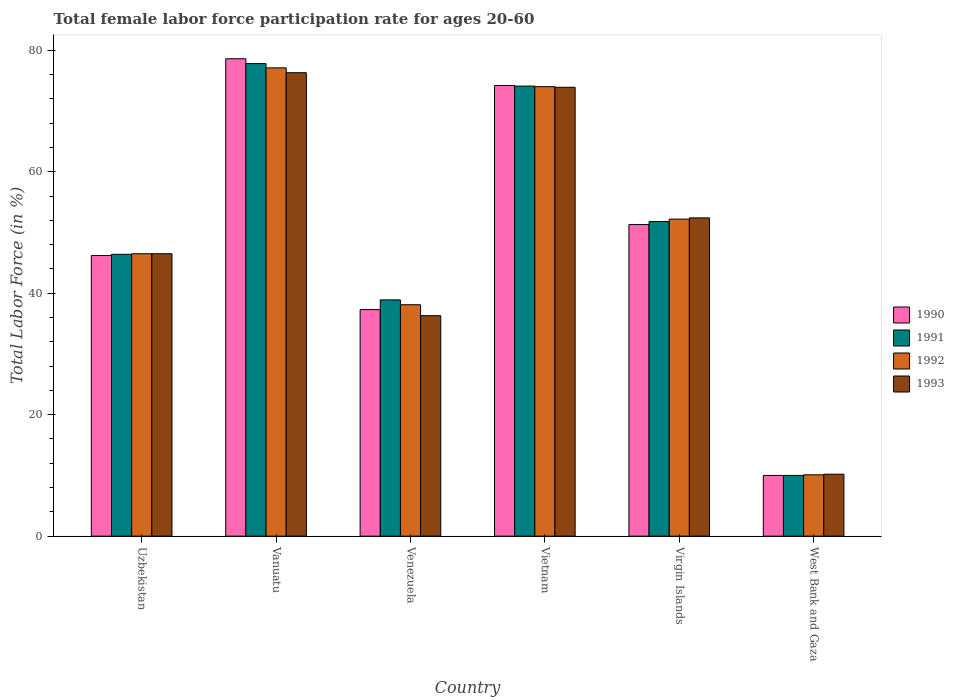How many groups of bars are there?
Offer a very short reply. 6. How many bars are there on the 1st tick from the left?
Offer a very short reply. 4. What is the label of the 5th group of bars from the left?
Your answer should be compact. Virgin Islands. What is the female labor force participation rate in 1991 in Virgin Islands?
Give a very brief answer. 51.8. Across all countries, what is the maximum female labor force participation rate in 1992?
Your answer should be compact. 77.1. Across all countries, what is the minimum female labor force participation rate in 1993?
Offer a very short reply. 10.2. In which country was the female labor force participation rate in 1990 maximum?
Make the answer very short. Vanuatu. In which country was the female labor force participation rate in 1992 minimum?
Provide a succinct answer. West Bank and Gaza. What is the total female labor force participation rate in 1993 in the graph?
Keep it short and to the point. 295.6. What is the difference between the female labor force participation rate in 1992 in Venezuela and that in Virgin Islands?
Your answer should be compact. -14.1. What is the difference between the female labor force participation rate in 1991 in Vanuatu and the female labor force participation rate in 1990 in West Bank and Gaza?
Your answer should be compact. 67.8. What is the average female labor force participation rate in 1992 per country?
Keep it short and to the point. 49.67. What is the ratio of the female labor force participation rate in 1992 in Vanuatu to that in West Bank and Gaza?
Ensure brevity in your answer.  7.63. Is the female labor force participation rate in 1991 in Uzbekistan less than that in Vanuatu?
Provide a succinct answer. Yes. What is the difference between the highest and the second highest female labor force participation rate in 1991?
Ensure brevity in your answer.  22.3. What is the difference between the highest and the lowest female labor force participation rate in 1992?
Keep it short and to the point. 67. In how many countries, is the female labor force participation rate in 1990 greater than the average female labor force participation rate in 1990 taken over all countries?
Your answer should be very brief. 3. Is it the case that in every country, the sum of the female labor force participation rate in 1993 and female labor force participation rate in 1991 is greater than the sum of female labor force participation rate in 1990 and female labor force participation rate in 1992?
Make the answer very short. No. What does the 4th bar from the right in Vanuatu represents?
Your response must be concise. 1990. Is it the case that in every country, the sum of the female labor force participation rate in 1991 and female labor force participation rate in 1992 is greater than the female labor force participation rate in 1993?
Make the answer very short. Yes. How many bars are there?
Provide a short and direct response. 24. Are all the bars in the graph horizontal?
Keep it short and to the point. No. Does the graph contain grids?
Provide a short and direct response. No. How are the legend labels stacked?
Offer a terse response. Vertical. What is the title of the graph?
Provide a succinct answer. Total female labor force participation rate for ages 20-60. Does "1974" appear as one of the legend labels in the graph?
Keep it short and to the point. No. What is the label or title of the X-axis?
Keep it short and to the point. Country. What is the Total Labor Force (in %) in 1990 in Uzbekistan?
Your answer should be very brief. 46.2. What is the Total Labor Force (in %) of 1991 in Uzbekistan?
Provide a short and direct response. 46.4. What is the Total Labor Force (in %) of 1992 in Uzbekistan?
Give a very brief answer. 46.5. What is the Total Labor Force (in %) in 1993 in Uzbekistan?
Your response must be concise. 46.5. What is the Total Labor Force (in %) in 1990 in Vanuatu?
Offer a terse response. 78.6. What is the Total Labor Force (in %) in 1991 in Vanuatu?
Give a very brief answer. 77.8. What is the Total Labor Force (in %) of 1992 in Vanuatu?
Your answer should be compact. 77.1. What is the Total Labor Force (in %) in 1993 in Vanuatu?
Your answer should be very brief. 76.3. What is the Total Labor Force (in %) of 1990 in Venezuela?
Provide a succinct answer. 37.3. What is the Total Labor Force (in %) in 1991 in Venezuela?
Make the answer very short. 38.9. What is the Total Labor Force (in %) in 1992 in Venezuela?
Offer a very short reply. 38.1. What is the Total Labor Force (in %) in 1993 in Venezuela?
Keep it short and to the point. 36.3. What is the Total Labor Force (in %) in 1990 in Vietnam?
Give a very brief answer. 74.2. What is the Total Labor Force (in %) in 1991 in Vietnam?
Ensure brevity in your answer.  74.1. What is the Total Labor Force (in %) of 1993 in Vietnam?
Provide a succinct answer. 73.9. What is the Total Labor Force (in %) of 1990 in Virgin Islands?
Ensure brevity in your answer.  51.3. What is the Total Labor Force (in %) in 1991 in Virgin Islands?
Your response must be concise. 51.8. What is the Total Labor Force (in %) of 1992 in Virgin Islands?
Your response must be concise. 52.2. What is the Total Labor Force (in %) of 1993 in Virgin Islands?
Provide a succinct answer. 52.4. What is the Total Labor Force (in %) in 1990 in West Bank and Gaza?
Offer a terse response. 10. What is the Total Labor Force (in %) in 1991 in West Bank and Gaza?
Keep it short and to the point. 10. What is the Total Labor Force (in %) in 1992 in West Bank and Gaza?
Offer a terse response. 10.1. What is the Total Labor Force (in %) in 1993 in West Bank and Gaza?
Make the answer very short. 10.2. Across all countries, what is the maximum Total Labor Force (in %) of 1990?
Offer a terse response. 78.6. Across all countries, what is the maximum Total Labor Force (in %) in 1991?
Ensure brevity in your answer.  77.8. Across all countries, what is the maximum Total Labor Force (in %) of 1992?
Offer a terse response. 77.1. Across all countries, what is the maximum Total Labor Force (in %) of 1993?
Your answer should be very brief. 76.3. Across all countries, what is the minimum Total Labor Force (in %) in 1992?
Give a very brief answer. 10.1. Across all countries, what is the minimum Total Labor Force (in %) in 1993?
Offer a very short reply. 10.2. What is the total Total Labor Force (in %) in 1990 in the graph?
Offer a very short reply. 297.6. What is the total Total Labor Force (in %) in 1991 in the graph?
Make the answer very short. 299. What is the total Total Labor Force (in %) in 1992 in the graph?
Offer a very short reply. 298. What is the total Total Labor Force (in %) of 1993 in the graph?
Ensure brevity in your answer.  295.6. What is the difference between the Total Labor Force (in %) of 1990 in Uzbekistan and that in Vanuatu?
Your response must be concise. -32.4. What is the difference between the Total Labor Force (in %) in 1991 in Uzbekistan and that in Vanuatu?
Offer a very short reply. -31.4. What is the difference between the Total Labor Force (in %) in 1992 in Uzbekistan and that in Vanuatu?
Your response must be concise. -30.6. What is the difference between the Total Labor Force (in %) of 1993 in Uzbekistan and that in Vanuatu?
Keep it short and to the point. -29.8. What is the difference between the Total Labor Force (in %) of 1991 in Uzbekistan and that in Venezuela?
Offer a very short reply. 7.5. What is the difference between the Total Labor Force (in %) in 1992 in Uzbekistan and that in Venezuela?
Offer a very short reply. 8.4. What is the difference between the Total Labor Force (in %) of 1991 in Uzbekistan and that in Vietnam?
Keep it short and to the point. -27.7. What is the difference between the Total Labor Force (in %) in 1992 in Uzbekistan and that in Vietnam?
Your response must be concise. -27.5. What is the difference between the Total Labor Force (in %) of 1993 in Uzbekistan and that in Vietnam?
Provide a short and direct response. -27.4. What is the difference between the Total Labor Force (in %) in 1990 in Uzbekistan and that in Virgin Islands?
Your answer should be compact. -5.1. What is the difference between the Total Labor Force (in %) of 1991 in Uzbekistan and that in Virgin Islands?
Keep it short and to the point. -5.4. What is the difference between the Total Labor Force (in %) in 1990 in Uzbekistan and that in West Bank and Gaza?
Provide a succinct answer. 36.2. What is the difference between the Total Labor Force (in %) in 1991 in Uzbekistan and that in West Bank and Gaza?
Offer a very short reply. 36.4. What is the difference between the Total Labor Force (in %) in 1992 in Uzbekistan and that in West Bank and Gaza?
Provide a succinct answer. 36.4. What is the difference between the Total Labor Force (in %) of 1993 in Uzbekistan and that in West Bank and Gaza?
Provide a short and direct response. 36.3. What is the difference between the Total Labor Force (in %) of 1990 in Vanuatu and that in Venezuela?
Provide a succinct answer. 41.3. What is the difference between the Total Labor Force (in %) of 1991 in Vanuatu and that in Venezuela?
Your answer should be very brief. 38.9. What is the difference between the Total Labor Force (in %) of 1990 in Vanuatu and that in Vietnam?
Your answer should be compact. 4.4. What is the difference between the Total Labor Force (in %) of 1991 in Vanuatu and that in Vietnam?
Keep it short and to the point. 3.7. What is the difference between the Total Labor Force (in %) in 1992 in Vanuatu and that in Vietnam?
Your answer should be very brief. 3.1. What is the difference between the Total Labor Force (in %) of 1993 in Vanuatu and that in Vietnam?
Provide a succinct answer. 2.4. What is the difference between the Total Labor Force (in %) of 1990 in Vanuatu and that in Virgin Islands?
Ensure brevity in your answer.  27.3. What is the difference between the Total Labor Force (in %) in 1991 in Vanuatu and that in Virgin Islands?
Keep it short and to the point. 26. What is the difference between the Total Labor Force (in %) of 1992 in Vanuatu and that in Virgin Islands?
Keep it short and to the point. 24.9. What is the difference between the Total Labor Force (in %) of 1993 in Vanuatu and that in Virgin Islands?
Provide a succinct answer. 23.9. What is the difference between the Total Labor Force (in %) of 1990 in Vanuatu and that in West Bank and Gaza?
Ensure brevity in your answer.  68.6. What is the difference between the Total Labor Force (in %) of 1991 in Vanuatu and that in West Bank and Gaza?
Ensure brevity in your answer.  67.8. What is the difference between the Total Labor Force (in %) in 1992 in Vanuatu and that in West Bank and Gaza?
Keep it short and to the point. 67. What is the difference between the Total Labor Force (in %) in 1993 in Vanuatu and that in West Bank and Gaza?
Ensure brevity in your answer.  66.1. What is the difference between the Total Labor Force (in %) in 1990 in Venezuela and that in Vietnam?
Make the answer very short. -36.9. What is the difference between the Total Labor Force (in %) of 1991 in Venezuela and that in Vietnam?
Your answer should be very brief. -35.2. What is the difference between the Total Labor Force (in %) of 1992 in Venezuela and that in Vietnam?
Offer a very short reply. -35.9. What is the difference between the Total Labor Force (in %) of 1993 in Venezuela and that in Vietnam?
Provide a short and direct response. -37.6. What is the difference between the Total Labor Force (in %) in 1990 in Venezuela and that in Virgin Islands?
Offer a terse response. -14. What is the difference between the Total Labor Force (in %) of 1992 in Venezuela and that in Virgin Islands?
Make the answer very short. -14.1. What is the difference between the Total Labor Force (in %) of 1993 in Venezuela and that in Virgin Islands?
Your answer should be very brief. -16.1. What is the difference between the Total Labor Force (in %) in 1990 in Venezuela and that in West Bank and Gaza?
Keep it short and to the point. 27.3. What is the difference between the Total Labor Force (in %) of 1991 in Venezuela and that in West Bank and Gaza?
Ensure brevity in your answer.  28.9. What is the difference between the Total Labor Force (in %) of 1992 in Venezuela and that in West Bank and Gaza?
Give a very brief answer. 28. What is the difference between the Total Labor Force (in %) in 1993 in Venezuela and that in West Bank and Gaza?
Make the answer very short. 26.1. What is the difference between the Total Labor Force (in %) in 1990 in Vietnam and that in Virgin Islands?
Ensure brevity in your answer.  22.9. What is the difference between the Total Labor Force (in %) in 1991 in Vietnam and that in Virgin Islands?
Your answer should be compact. 22.3. What is the difference between the Total Labor Force (in %) of 1992 in Vietnam and that in Virgin Islands?
Keep it short and to the point. 21.8. What is the difference between the Total Labor Force (in %) in 1990 in Vietnam and that in West Bank and Gaza?
Your response must be concise. 64.2. What is the difference between the Total Labor Force (in %) of 1991 in Vietnam and that in West Bank and Gaza?
Your answer should be very brief. 64.1. What is the difference between the Total Labor Force (in %) in 1992 in Vietnam and that in West Bank and Gaza?
Offer a very short reply. 63.9. What is the difference between the Total Labor Force (in %) of 1993 in Vietnam and that in West Bank and Gaza?
Offer a terse response. 63.7. What is the difference between the Total Labor Force (in %) of 1990 in Virgin Islands and that in West Bank and Gaza?
Make the answer very short. 41.3. What is the difference between the Total Labor Force (in %) of 1991 in Virgin Islands and that in West Bank and Gaza?
Provide a succinct answer. 41.8. What is the difference between the Total Labor Force (in %) in 1992 in Virgin Islands and that in West Bank and Gaza?
Provide a short and direct response. 42.1. What is the difference between the Total Labor Force (in %) in 1993 in Virgin Islands and that in West Bank and Gaza?
Offer a very short reply. 42.2. What is the difference between the Total Labor Force (in %) of 1990 in Uzbekistan and the Total Labor Force (in %) of 1991 in Vanuatu?
Keep it short and to the point. -31.6. What is the difference between the Total Labor Force (in %) in 1990 in Uzbekistan and the Total Labor Force (in %) in 1992 in Vanuatu?
Keep it short and to the point. -30.9. What is the difference between the Total Labor Force (in %) of 1990 in Uzbekistan and the Total Labor Force (in %) of 1993 in Vanuatu?
Your answer should be very brief. -30.1. What is the difference between the Total Labor Force (in %) in 1991 in Uzbekistan and the Total Labor Force (in %) in 1992 in Vanuatu?
Your answer should be compact. -30.7. What is the difference between the Total Labor Force (in %) of 1991 in Uzbekistan and the Total Labor Force (in %) of 1993 in Vanuatu?
Give a very brief answer. -29.9. What is the difference between the Total Labor Force (in %) in 1992 in Uzbekistan and the Total Labor Force (in %) in 1993 in Vanuatu?
Your response must be concise. -29.8. What is the difference between the Total Labor Force (in %) in 1990 in Uzbekistan and the Total Labor Force (in %) in 1991 in Venezuela?
Give a very brief answer. 7.3. What is the difference between the Total Labor Force (in %) of 1990 in Uzbekistan and the Total Labor Force (in %) of 1993 in Venezuela?
Offer a very short reply. 9.9. What is the difference between the Total Labor Force (in %) of 1991 in Uzbekistan and the Total Labor Force (in %) of 1993 in Venezuela?
Provide a succinct answer. 10.1. What is the difference between the Total Labor Force (in %) of 1990 in Uzbekistan and the Total Labor Force (in %) of 1991 in Vietnam?
Ensure brevity in your answer.  -27.9. What is the difference between the Total Labor Force (in %) of 1990 in Uzbekistan and the Total Labor Force (in %) of 1992 in Vietnam?
Keep it short and to the point. -27.8. What is the difference between the Total Labor Force (in %) in 1990 in Uzbekistan and the Total Labor Force (in %) in 1993 in Vietnam?
Your response must be concise. -27.7. What is the difference between the Total Labor Force (in %) of 1991 in Uzbekistan and the Total Labor Force (in %) of 1992 in Vietnam?
Your answer should be very brief. -27.6. What is the difference between the Total Labor Force (in %) of 1991 in Uzbekistan and the Total Labor Force (in %) of 1993 in Vietnam?
Provide a short and direct response. -27.5. What is the difference between the Total Labor Force (in %) in 1992 in Uzbekistan and the Total Labor Force (in %) in 1993 in Vietnam?
Provide a succinct answer. -27.4. What is the difference between the Total Labor Force (in %) of 1990 in Uzbekistan and the Total Labor Force (in %) of 1991 in Virgin Islands?
Offer a very short reply. -5.6. What is the difference between the Total Labor Force (in %) of 1990 in Uzbekistan and the Total Labor Force (in %) of 1993 in Virgin Islands?
Your answer should be very brief. -6.2. What is the difference between the Total Labor Force (in %) of 1991 in Uzbekistan and the Total Labor Force (in %) of 1992 in Virgin Islands?
Make the answer very short. -5.8. What is the difference between the Total Labor Force (in %) in 1990 in Uzbekistan and the Total Labor Force (in %) in 1991 in West Bank and Gaza?
Offer a terse response. 36.2. What is the difference between the Total Labor Force (in %) in 1990 in Uzbekistan and the Total Labor Force (in %) in 1992 in West Bank and Gaza?
Your answer should be compact. 36.1. What is the difference between the Total Labor Force (in %) of 1990 in Uzbekistan and the Total Labor Force (in %) of 1993 in West Bank and Gaza?
Provide a short and direct response. 36. What is the difference between the Total Labor Force (in %) in 1991 in Uzbekistan and the Total Labor Force (in %) in 1992 in West Bank and Gaza?
Your answer should be compact. 36.3. What is the difference between the Total Labor Force (in %) of 1991 in Uzbekistan and the Total Labor Force (in %) of 1993 in West Bank and Gaza?
Make the answer very short. 36.2. What is the difference between the Total Labor Force (in %) of 1992 in Uzbekistan and the Total Labor Force (in %) of 1993 in West Bank and Gaza?
Provide a succinct answer. 36.3. What is the difference between the Total Labor Force (in %) of 1990 in Vanuatu and the Total Labor Force (in %) of 1991 in Venezuela?
Make the answer very short. 39.7. What is the difference between the Total Labor Force (in %) of 1990 in Vanuatu and the Total Labor Force (in %) of 1992 in Venezuela?
Give a very brief answer. 40.5. What is the difference between the Total Labor Force (in %) of 1990 in Vanuatu and the Total Labor Force (in %) of 1993 in Venezuela?
Give a very brief answer. 42.3. What is the difference between the Total Labor Force (in %) of 1991 in Vanuatu and the Total Labor Force (in %) of 1992 in Venezuela?
Offer a very short reply. 39.7. What is the difference between the Total Labor Force (in %) in 1991 in Vanuatu and the Total Labor Force (in %) in 1993 in Venezuela?
Offer a terse response. 41.5. What is the difference between the Total Labor Force (in %) in 1992 in Vanuatu and the Total Labor Force (in %) in 1993 in Venezuela?
Your response must be concise. 40.8. What is the difference between the Total Labor Force (in %) of 1990 in Vanuatu and the Total Labor Force (in %) of 1991 in Vietnam?
Offer a terse response. 4.5. What is the difference between the Total Labor Force (in %) of 1990 in Vanuatu and the Total Labor Force (in %) of 1992 in Vietnam?
Ensure brevity in your answer.  4.6. What is the difference between the Total Labor Force (in %) in 1990 in Vanuatu and the Total Labor Force (in %) in 1993 in Vietnam?
Your answer should be compact. 4.7. What is the difference between the Total Labor Force (in %) in 1991 in Vanuatu and the Total Labor Force (in %) in 1993 in Vietnam?
Your answer should be very brief. 3.9. What is the difference between the Total Labor Force (in %) in 1992 in Vanuatu and the Total Labor Force (in %) in 1993 in Vietnam?
Offer a very short reply. 3.2. What is the difference between the Total Labor Force (in %) of 1990 in Vanuatu and the Total Labor Force (in %) of 1991 in Virgin Islands?
Your answer should be compact. 26.8. What is the difference between the Total Labor Force (in %) in 1990 in Vanuatu and the Total Labor Force (in %) in 1992 in Virgin Islands?
Your response must be concise. 26.4. What is the difference between the Total Labor Force (in %) of 1990 in Vanuatu and the Total Labor Force (in %) of 1993 in Virgin Islands?
Ensure brevity in your answer.  26.2. What is the difference between the Total Labor Force (in %) of 1991 in Vanuatu and the Total Labor Force (in %) of 1992 in Virgin Islands?
Give a very brief answer. 25.6. What is the difference between the Total Labor Force (in %) in 1991 in Vanuatu and the Total Labor Force (in %) in 1993 in Virgin Islands?
Offer a terse response. 25.4. What is the difference between the Total Labor Force (in %) in 1992 in Vanuatu and the Total Labor Force (in %) in 1993 in Virgin Islands?
Your answer should be compact. 24.7. What is the difference between the Total Labor Force (in %) in 1990 in Vanuatu and the Total Labor Force (in %) in 1991 in West Bank and Gaza?
Your answer should be very brief. 68.6. What is the difference between the Total Labor Force (in %) of 1990 in Vanuatu and the Total Labor Force (in %) of 1992 in West Bank and Gaza?
Keep it short and to the point. 68.5. What is the difference between the Total Labor Force (in %) in 1990 in Vanuatu and the Total Labor Force (in %) in 1993 in West Bank and Gaza?
Your answer should be very brief. 68.4. What is the difference between the Total Labor Force (in %) in 1991 in Vanuatu and the Total Labor Force (in %) in 1992 in West Bank and Gaza?
Ensure brevity in your answer.  67.7. What is the difference between the Total Labor Force (in %) of 1991 in Vanuatu and the Total Labor Force (in %) of 1993 in West Bank and Gaza?
Your answer should be compact. 67.6. What is the difference between the Total Labor Force (in %) in 1992 in Vanuatu and the Total Labor Force (in %) in 1993 in West Bank and Gaza?
Offer a very short reply. 66.9. What is the difference between the Total Labor Force (in %) in 1990 in Venezuela and the Total Labor Force (in %) in 1991 in Vietnam?
Make the answer very short. -36.8. What is the difference between the Total Labor Force (in %) of 1990 in Venezuela and the Total Labor Force (in %) of 1992 in Vietnam?
Give a very brief answer. -36.7. What is the difference between the Total Labor Force (in %) in 1990 in Venezuela and the Total Labor Force (in %) in 1993 in Vietnam?
Make the answer very short. -36.6. What is the difference between the Total Labor Force (in %) of 1991 in Venezuela and the Total Labor Force (in %) of 1992 in Vietnam?
Your response must be concise. -35.1. What is the difference between the Total Labor Force (in %) of 1991 in Venezuela and the Total Labor Force (in %) of 1993 in Vietnam?
Your answer should be very brief. -35. What is the difference between the Total Labor Force (in %) in 1992 in Venezuela and the Total Labor Force (in %) in 1993 in Vietnam?
Keep it short and to the point. -35.8. What is the difference between the Total Labor Force (in %) of 1990 in Venezuela and the Total Labor Force (in %) of 1991 in Virgin Islands?
Your response must be concise. -14.5. What is the difference between the Total Labor Force (in %) in 1990 in Venezuela and the Total Labor Force (in %) in 1992 in Virgin Islands?
Keep it short and to the point. -14.9. What is the difference between the Total Labor Force (in %) of 1990 in Venezuela and the Total Labor Force (in %) of 1993 in Virgin Islands?
Offer a terse response. -15.1. What is the difference between the Total Labor Force (in %) in 1992 in Venezuela and the Total Labor Force (in %) in 1993 in Virgin Islands?
Provide a succinct answer. -14.3. What is the difference between the Total Labor Force (in %) in 1990 in Venezuela and the Total Labor Force (in %) in 1991 in West Bank and Gaza?
Ensure brevity in your answer.  27.3. What is the difference between the Total Labor Force (in %) in 1990 in Venezuela and the Total Labor Force (in %) in 1992 in West Bank and Gaza?
Your response must be concise. 27.2. What is the difference between the Total Labor Force (in %) in 1990 in Venezuela and the Total Labor Force (in %) in 1993 in West Bank and Gaza?
Your answer should be very brief. 27.1. What is the difference between the Total Labor Force (in %) of 1991 in Venezuela and the Total Labor Force (in %) of 1992 in West Bank and Gaza?
Your answer should be compact. 28.8. What is the difference between the Total Labor Force (in %) of 1991 in Venezuela and the Total Labor Force (in %) of 1993 in West Bank and Gaza?
Offer a very short reply. 28.7. What is the difference between the Total Labor Force (in %) in 1992 in Venezuela and the Total Labor Force (in %) in 1993 in West Bank and Gaza?
Provide a short and direct response. 27.9. What is the difference between the Total Labor Force (in %) of 1990 in Vietnam and the Total Labor Force (in %) of 1991 in Virgin Islands?
Provide a succinct answer. 22.4. What is the difference between the Total Labor Force (in %) in 1990 in Vietnam and the Total Labor Force (in %) in 1992 in Virgin Islands?
Provide a succinct answer. 22. What is the difference between the Total Labor Force (in %) in 1990 in Vietnam and the Total Labor Force (in %) in 1993 in Virgin Islands?
Your answer should be very brief. 21.8. What is the difference between the Total Labor Force (in %) of 1991 in Vietnam and the Total Labor Force (in %) of 1992 in Virgin Islands?
Give a very brief answer. 21.9. What is the difference between the Total Labor Force (in %) in 1991 in Vietnam and the Total Labor Force (in %) in 1993 in Virgin Islands?
Offer a very short reply. 21.7. What is the difference between the Total Labor Force (in %) of 1992 in Vietnam and the Total Labor Force (in %) of 1993 in Virgin Islands?
Make the answer very short. 21.6. What is the difference between the Total Labor Force (in %) of 1990 in Vietnam and the Total Labor Force (in %) of 1991 in West Bank and Gaza?
Give a very brief answer. 64.2. What is the difference between the Total Labor Force (in %) of 1990 in Vietnam and the Total Labor Force (in %) of 1992 in West Bank and Gaza?
Your answer should be compact. 64.1. What is the difference between the Total Labor Force (in %) of 1991 in Vietnam and the Total Labor Force (in %) of 1992 in West Bank and Gaza?
Offer a very short reply. 64. What is the difference between the Total Labor Force (in %) in 1991 in Vietnam and the Total Labor Force (in %) in 1993 in West Bank and Gaza?
Give a very brief answer. 63.9. What is the difference between the Total Labor Force (in %) of 1992 in Vietnam and the Total Labor Force (in %) of 1993 in West Bank and Gaza?
Your response must be concise. 63.8. What is the difference between the Total Labor Force (in %) of 1990 in Virgin Islands and the Total Labor Force (in %) of 1991 in West Bank and Gaza?
Ensure brevity in your answer.  41.3. What is the difference between the Total Labor Force (in %) in 1990 in Virgin Islands and the Total Labor Force (in %) in 1992 in West Bank and Gaza?
Provide a short and direct response. 41.2. What is the difference between the Total Labor Force (in %) in 1990 in Virgin Islands and the Total Labor Force (in %) in 1993 in West Bank and Gaza?
Your answer should be very brief. 41.1. What is the difference between the Total Labor Force (in %) in 1991 in Virgin Islands and the Total Labor Force (in %) in 1992 in West Bank and Gaza?
Offer a very short reply. 41.7. What is the difference between the Total Labor Force (in %) in 1991 in Virgin Islands and the Total Labor Force (in %) in 1993 in West Bank and Gaza?
Keep it short and to the point. 41.6. What is the average Total Labor Force (in %) in 1990 per country?
Make the answer very short. 49.6. What is the average Total Labor Force (in %) in 1991 per country?
Offer a terse response. 49.83. What is the average Total Labor Force (in %) of 1992 per country?
Make the answer very short. 49.67. What is the average Total Labor Force (in %) of 1993 per country?
Make the answer very short. 49.27. What is the difference between the Total Labor Force (in %) of 1990 and Total Labor Force (in %) of 1991 in Uzbekistan?
Your response must be concise. -0.2. What is the difference between the Total Labor Force (in %) in 1990 and Total Labor Force (in %) in 1993 in Uzbekistan?
Your answer should be compact. -0.3. What is the difference between the Total Labor Force (in %) of 1991 and Total Labor Force (in %) of 1992 in Uzbekistan?
Ensure brevity in your answer.  -0.1. What is the difference between the Total Labor Force (in %) of 1991 and Total Labor Force (in %) of 1992 in Vanuatu?
Your answer should be very brief. 0.7. What is the difference between the Total Labor Force (in %) of 1991 and Total Labor Force (in %) of 1993 in Vanuatu?
Give a very brief answer. 1.5. What is the difference between the Total Labor Force (in %) of 1990 and Total Labor Force (in %) of 1993 in Venezuela?
Keep it short and to the point. 1. What is the difference between the Total Labor Force (in %) in 1991 and Total Labor Force (in %) in 1992 in Venezuela?
Keep it short and to the point. 0.8. What is the difference between the Total Labor Force (in %) of 1991 and Total Labor Force (in %) of 1993 in Venezuela?
Give a very brief answer. 2.6. What is the difference between the Total Labor Force (in %) in 1992 and Total Labor Force (in %) in 1993 in Venezuela?
Make the answer very short. 1.8. What is the difference between the Total Labor Force (in %) of 1990 and Total Labor Force (in %) of 1991 in Vietnam?
Your answer should be compact. 0.1. What is the difference between the Total Labor Force (in %) in 1990 and Total Labor Force (in %) in 1992 in Vietnam?
Make the answer very short. 0.2. What is the difference between the Total Labor Force (in %) in 1990 and Total Labor Force (in %) in 1993 in Vietnam?
Provide a short and direct response. 0.3. What is the difference between the Total Labor Force (in %) of 1991 and Total Labor Force (in %) of 1993 in Vietnam?
Your answer should be compact. 0.2. What is the difference between the Total Labor Force (in %) of 1990 and Total Labor Force (in %) of 1993 in Virgin Islands?
Provide a succinct answer. -1.1. What is the difference between the Total Labor Force (in %) of 1991 and Total Labor Force (in %) of 1993 in Virgin Islands?
Make the answer very short. -0.6. What is the difference between the Total Labor Force (in %) of 1992 and Total Labor Force (in %) of 1993 in Virgin Islands?
Provide a succinct answer. -0.2. What is the difference between the Total Labor Force (in %) of 1990 and Total Labor Force (in %) of 1992 in West Bank and Gaza?
Your response must be concise. -0.1. What is the difference between the Total Labor Force (in %) in 1990 and Total Labor Force (in %) in 1993 in West Bank and Gaza?
Your answer should be compact. -0.2. What is the difference between the Total Labor Force (in %) in 1991 and Total Labor Force (in %) in 1992 in West Bank and Gaza?
Offer a very short reply. -0.1. What is the difference between the Total Labor Force (in %) of 1992 and Total Labor Force (in %) of 1993 in West Bank and Gaza?
Ensure brevity in your answer.  -0.1. What is the ratio of the Total Labor Force (in %) of 1990 in Uzbekistan to that in Vanuatu?
Provide a succinct answer. 0.59. What is the ratio of the Total Labor Force (in %) in 1991 in Uzbekistan to that in Vanuatu?
Provide a succinct answer. 0.6. What is the ratio of the Total Labor Force (in %) in 1992 in Uzbekistan to that in Vanuatu?
Ensure brevity in your answer.  0.6. What is the ratio of the Total Labor Force (in %) in 1993 in Uzbekistan to that in Vanuatu?
Keep it short and to the point. 0.61. What is the ratio of the Total Labor Force (in %) of 1990 in Uzbekistan to that in Venezuela?
Ensure brevity in your answer.  1.24. What is the ratio of the Total Labor Force (in %) in 1991 in Uzbekistan to that in Venezuela?
Your answer should be compact. 1.19. What is the ratio of the Total Labor Force (in %) of 1992 in Uzbekistan to that in Venezuela?
Give a very brief answer. 1.22. What is the ratio of the Total Labor Force (in %) in 1993 in Uzbekistan to that in Venezuela?
Keep it short and to the point. 1.28. What is the ratio of the Total Labor Force (in %) of 1990 in Uzbekistan to that in Vietnam?
Provide a succinct answer. 0.62. What is the ratio of the Total Labor Force (in %) in 1991 in Uzbekistan to that in Vietnam?
Give a very brief answer. 0.63. What is the ratio of the Total Labor Force (in %) of 1992 in Uzbekistan to that in Vietnam?
Give a very brief answer. 0.63. What is the ratio of the Total Labor Force (in %) of 1993 in Uzbekistan to that in Vietnam?
Offer a very short reply. 0.63. What is the ratio of the Total Labor Force (in %) of 1990 in Uzbekistan to that in Virgin Islands?
Your answer should be compact. 0.9. What is the ratio of the Total Labor Force (in %) in 1991 in Uzbekistan to that in Virgin Islands?
Your answer should be compact. 0.9. What is the ratio of the Total Labor Force (in %) in 1992 in Uzbekistan to that in Virgin Islands?
Offer a very short reply. 0.89. What is the ratio of the Total Labor Force (in %) in 1993 in Uzbekistan to that in Virgin Islands?
Keep it short and to the point. 0.89. What is the ratio of the Total Labor Force (in %) of 1990 in Uzbekistan to that in West Bank and Gaza?
Provide a short and direct response. 4.62. What is the ratio of the Total Labor Force (in %) in 1991 in Uzbekistan to that in West Bank and Gaza?
Your response must be concise. 4.64. What is the ratio of the Total Labor Force (in %) in 1992 in Uzbekistan to that in West Bank and Gaza?
Offer a terse response. 4.6. What is the ratio of the Total Labor Force (in %) in 1993 in Uzbekistan to that in West Bank and Gaza?
Give a very brief answer. 4.56. What is the ratio of the Total Labor Force (in %) of 1990 in Vanuatu to that in Venezuela?
Your response must be concise. 2.11. What is the ratio of the Total Labor Force (in %) in 1992 in Vanuatu to that in Venezuela?
Ensure brevity in your answer.  2.02. What is the ratio of the Total Labor Force (in %) of 1993 in Vanuatu to that in Venezuela?
Offer a very short reply. 2.1. What is the ratio of the Total Labor Force (in %) of 1990 in Vanuatu to that in Vietnam?
Your response must be concise. 1.06. What is the ratio of the Total Labor Force (in %) in 1991 in Vanuatu to that in Vietnam?
Give a very brief answer. 1.05. What is the ratio of the Total Labor Force (in %) of 1992 in Vanuatu to that in Vietnam?
Give a very brief answer. 1.04. What is the ratio of the Total Labor Force (in %) in 1993 in Vanuatu to that in Vietnam?
Offer a very short reply. 1.03. What is the ratio of the Total Labor Force (in %) in 1990 in Vanuatu to that in Virgin Islands?
Provide a succinct answer. 1.53. What is the ratio of the Total Labor Force (in %) in 1991 in Vanuatu to that in Virgin Islands?
Ensure brevity in your answer.  1.5. What is the ratio of the Total Labor Force (in %) of 1992 in Vanuatu to that in Virgin Islands?
Offer a terse response. 1.48. What is the ratio of the Total Labor Force (in %) of 1993 in Vanuatu to that in Virgin Islands?
Make the answer very short. 1.46. What is the ratio of the Total Labor Force (in %) of 1990 in Vanuatu to that in West Bank and Gaza?
Provide a succinct answer. 7.86. What is the ratio of the Total Labor Force (in %) in 1991 in Vanuatu to that in West Bank and Gaza?
Ensure brevity in your answer.  7.78. What is the ratio of the Total Labor Force (in %) of 1992 in Vanuatu to that in West Bank and Gaza?
Keep it short and to the point. 7.63. What is the ratio of the Total Labor Force (in %) in 1993 in Vanuatu to that in West Bank and Gaza?
Keep it short and to the point. 7.48. What is the ratio of the Total Labor Force (in %) in 1990 in Venezuela to that in Vietnam?
Your response must be concise. 0.5. What is the ratio of the Total Labor Force (in %) of 1991 in Venezuela to that in Vietnam?
Your response must be concise. 0.53. What is the ratio of the Total Labor Force (in %) of 1992 in Venezuela to that in Vietnam?
Your answer should be very brief. 0.51. What is the ratio of the Total Labor Force (in %) in 1993 in Venezuela to that in Vietnam?
Ensure brevity in your answer.  0.49. What is the ratio of the Total Labor Force (in %) of 1990 in Venezuela to that in Virgin Islands?
Offer a very short reply. 0.73. What is the ratio of the Total Labor Force (in %) in 1991 in Venezuela to that in Virgin Islands?
Keep it short and to the point. 0.75. What is the ratio of the Total Labor Force (in %) in 1992 in Venezuela to that in Virgin Islands?
Your answer should be very brief. 0.73. What is the ratio of the Total Labor Force (in %) in 1993 in Venezuela to that in Virgin Islands?
Provide a short and direct response. 0.69. What is the ratio of the Total Labor Force (in %) of 1990 in Venezuela to that in West Bank and Gaza?
Your answer should be very brief. 3.73. What is the ratio of the Total Labor Force (in %) in 1991 in Venezuela to that in West Bank and Gaza?
Ensure brevity in your answer.  3.89. What is the ratio of the Total Labor Force (in %) of 1992 in Venezuela to that in West Bank and Gaza?
Offer a very short reply. 3.77. What is the ratio of the Total Labor Force (in %) of 1993 in Venezuela to that in West Bank and Gaza?
Provide a succinct answer. 3.56. What is the ratio of the Total Labor Force (in %) of 1990 in Vietnam to that in Virgin Islands?
Your answer should be very brief. 1.45. What is the ratio of the Total Labor Force (in %) in 1991 in Vietnam to that in Virgin Islands?
Your answer should be very brief. 1.43. What is the ratio of the Total Labor Force (in %) in 1992 in Vietnam to that in Virgin Islands?
Provide a succinct answer. 1.42. What is the ratio of the Total Labor Force (in %) of 1993 in Vietnam to that in Virgin Islands?
Offer a terse response. 1.41. What is the ratio of the Total Labor Force (in %) in 1990 in Vietnam to that in West Bank and Gaza?
Give a very brief answer. 7.42. What is the ratio of the Total Labor Force (in %) in 1991 in Vietnam to that in West Bank and Gaza?
Your answer should be compact. 7.41. What is the ratio of the Total Labor Force (in %) of 1992 in Vietnam to that in West Bank and Gaza?
Give a very brief answer. 7.33. What is the ratio of the Total Labor Force (in %) of 1993 in Vietnam to that in West Bank and Gaza?
Your answer should be very brief. 7.25. What is the ratio of the Total Labor Force (in %) of 1990 in Virgin Islands to that in West Bank and Gaza?
Offer a very short reply. 5.13. What is the ratio of the Total Labor Force (in %) of 1991 in Virgin Islands to that in West Bank and Gaza?
Make the answer very short. 5.18. What is the ratio of the Total Labor Force (in %) of 1992 in Virgin Islands to that in West Bank and Gaza?
Give a very brief answer. 5.17. What is the ratio of the Total Labor Force (in %) in 1993 in Virgin Islands to that in West Bank and Gaza?
Your response must be concise. 5.14. What is the difference between the highest and the second highest Total Labor Force (in %) of 1993?
Provide a short and direct response. 2.4. What is the difference between the highest and the lowest Total Labor Force (in %) of 1990?
Your answer should be compact. 68.6. What is the difference between the highest and the lowest Total Labor Force (in %) of 1991?
Ensure brevity in your answer.  67.8. What is the difference between the highest and the lowest Total Labor Force (in %) in 1992?
Offer a terse response. 67. What is the difference between the highest and the lowest Total Labor Force (in %) of 1993?
Your answer should be compact. 66.1. 